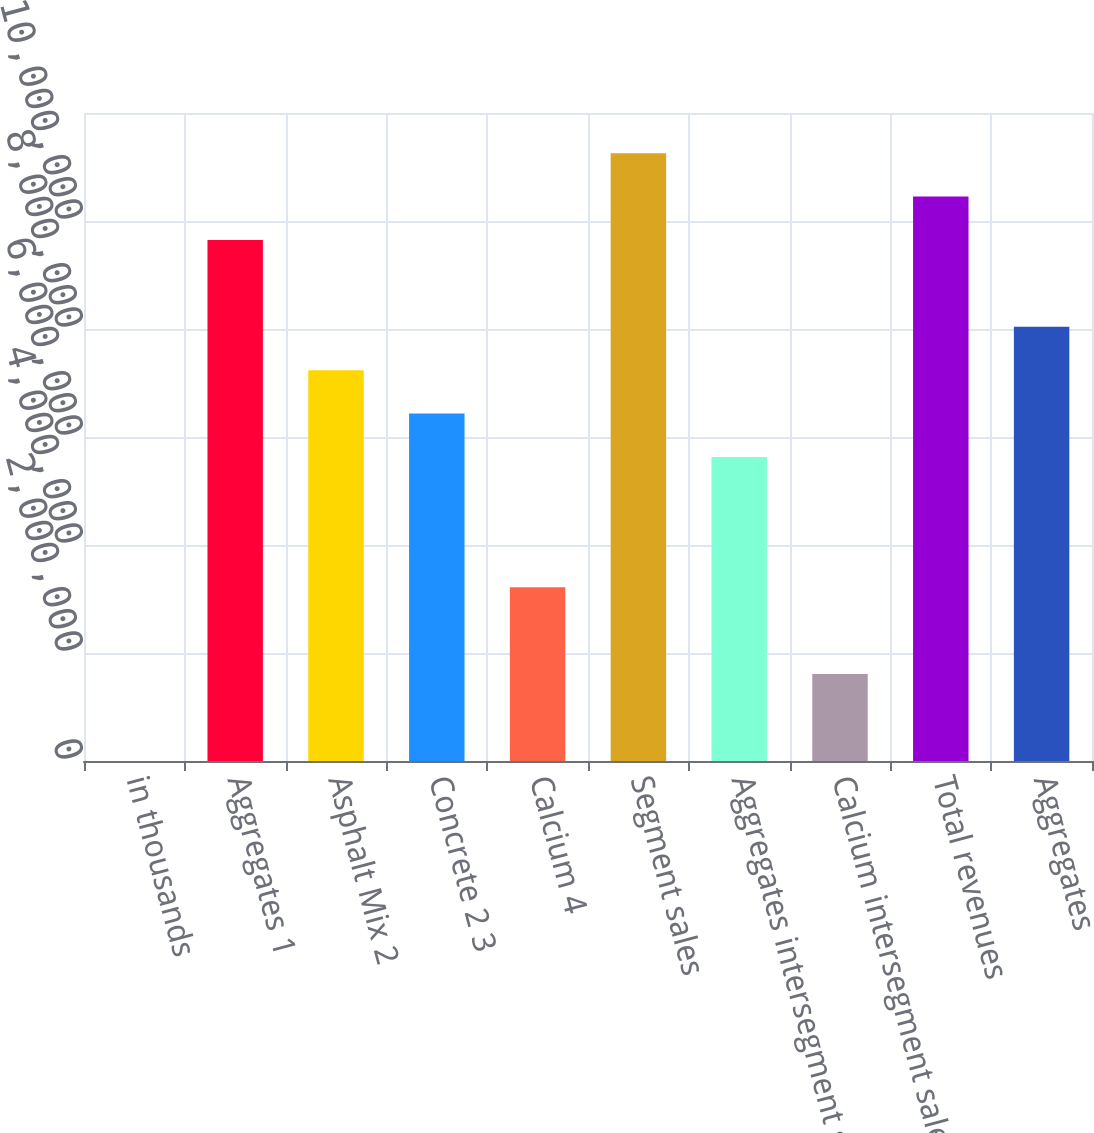Convert chart to OTSL. <chart><loc_0><loc_0><loc_500><loc_500><bar_chart><fcel>in thousands<fcel>Aggregates 1<fcel>Asphalt Mix 2<fcel>Concrete 2 3<fcel>Calcium 4<fcel>Segment sales<fcel>Aggregates intersegment sales<fcel>Calcium intersegment sales<fcel>Total revenues<fcel>Aggregates<nl><fcel>2014<fcel>9.64891e+06<fcel>7.23719e+06<fcel>6.43328e+06<fcel>3.21765e+06<fcel>1.12567e+07<fcel>5.62937e+06<fcel>1.60983e+06<fcel>1.04528e+07<fcel>8.0411e+06<nl></chart> 